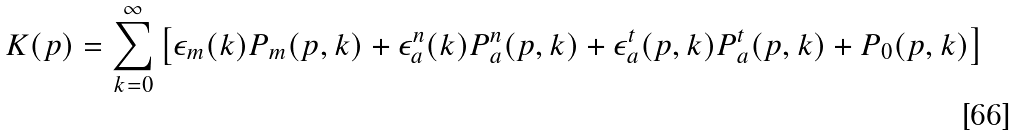Convert formula to latex. <formula><loc_0><loc_0><loc_500><loc_500>K ( p ) = \sum _ { k = 0 } ^ { \infty } \left [ \epsilon _ { m } ( k ) P _ { m } ( p , k ) + \epsilon _ { a } ^ { n } ( k ) P _ { a } ^ { n } ( p , k ) + \epsilon _ { a } ^ { t } ( p , k ) P _ { a } ^ { t } ( p , k ) + P _ { 0 } ( p , k ) \right ]</formula> 